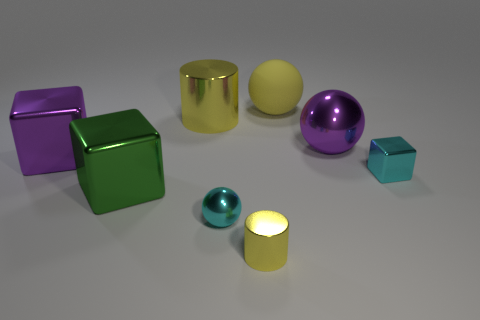There is a shiny ball right of the rubber ball; is its size the same as the big yellow metal thing?
Give a very brief answer. Yes. The big shiny object that is the same shape as the big rubber object is what color?
Keep it short and to the point. Purple. What shape is the purple metallic thing that is right of the small yellow shiny thing?
Provide a short and direct response. Sphere. How many other tiny yellow metallic things have the same shape as the tiny yellow shiny thing?
Offer a very short reply. 0. Do the small thing that is left of the small cylinder and the cube right of the big green shiny block have the same color?
Offer a terse response. Yes. What number of objects are either small purple metallic cubes or purple things?
Your response must be concise. 2. How many purple blocks have the same material as the large green thing?
Offer a very short reply. 1. Is the number of small purple rubber cylinders less than the number of yellow metal cylinders?
Offer a terse response. Yes. Is the material of the large thing that is on the right side of the yellow matte thing the same as the yellow sphere?
Your answer should be compact. No. How many cylinders are purple metal objects or matte objects?
Keep it short and to the point. 0. 